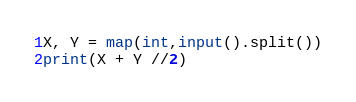Convert code to text. <code><loc_0><loc_0><loc_500><loc_500><_Python_>X, Y = map(int,input().split())
print(X + Y //2)</code> 